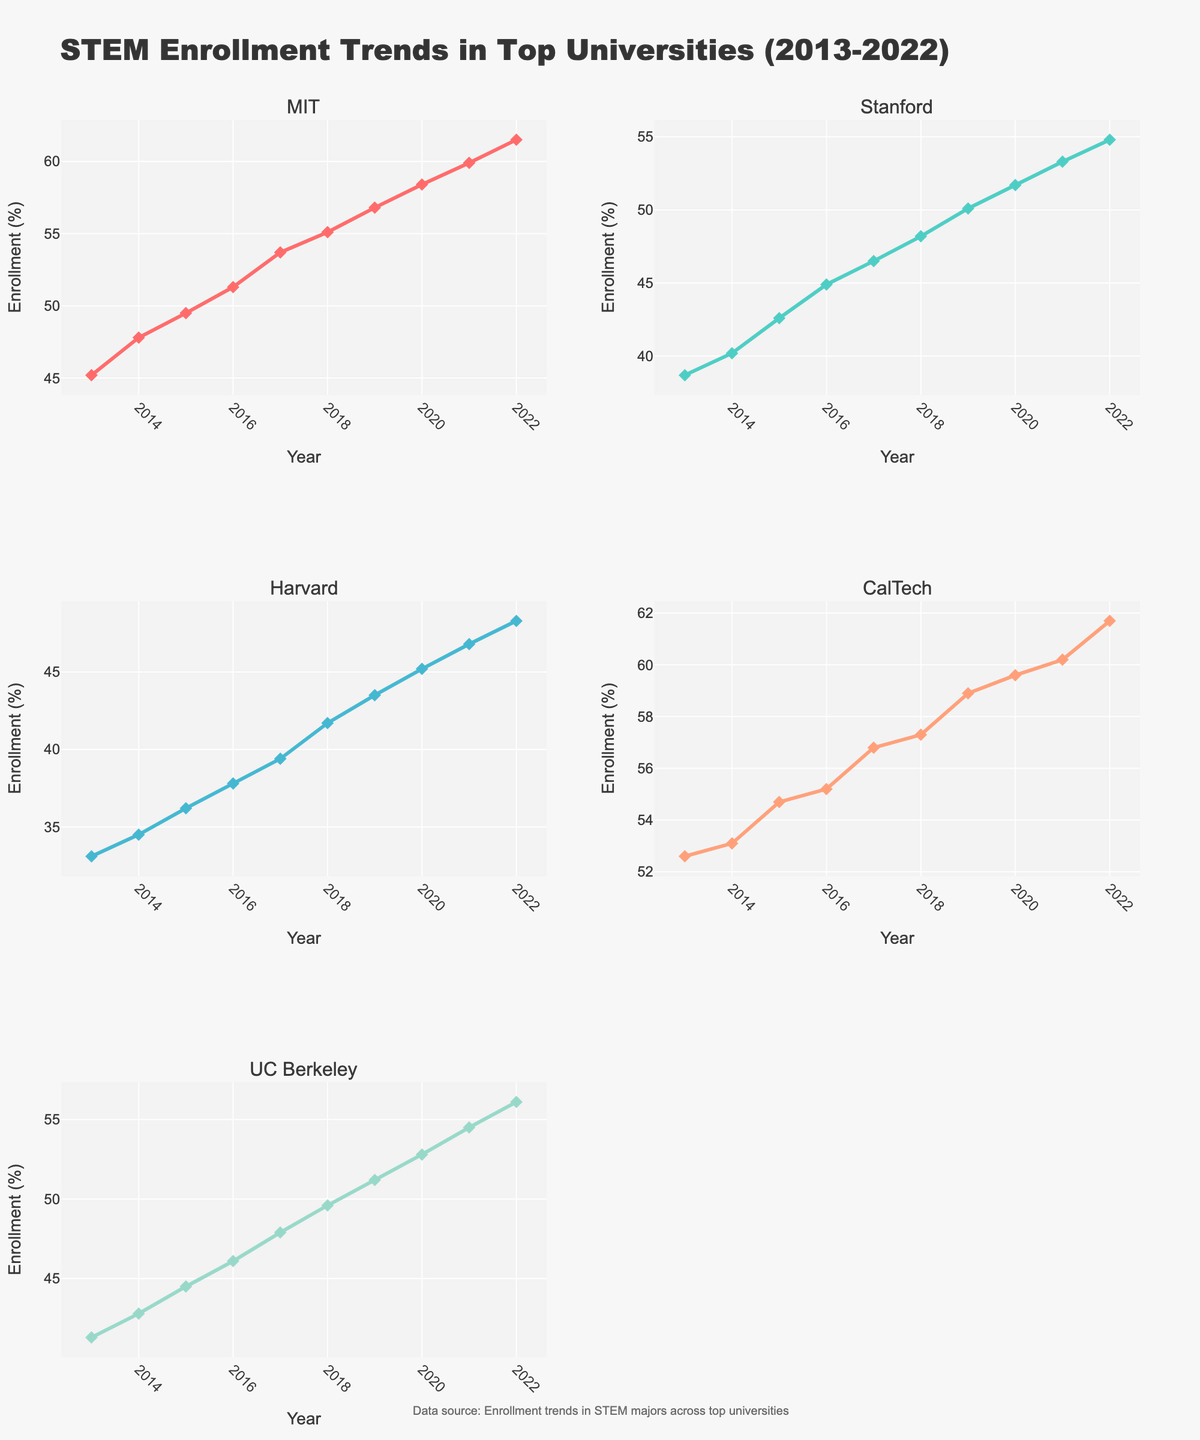What's the title of the figure? The title is usually placed at the top of a figure and it summarizes what the figure is about. Here, the title is "STEM Enrollment Trends in Top Universities (2013-2022)".
Answer: STEM Enrollment Trends in Top Universities (2013-2022) Which university had the highest STEM enrollment in 2022? To determine the university with the highest enrollment in 2022, observe the data points or lines corresponding to 2022 in each subplot. MIT's plot shows the highest value at approximately 61.5%.
Answer: MIT How did STEM enrollment at Harvard change from 2013 to 2022? Look at the subplot for Harvard. Observe the trendline from 2013 to 2022. Harvard's enrollment started around 33.1% in 2013 and increased to approximately 48.3% in 2022.
Answer: Increased Which university had the lowest increase in STEM enrollment over the decade? Calculate the increase for each university by subtracting the 2013 value from the 2022 value for each subplot. The smallest increment is seen for Harvard (48.3% - 33.1% = 15.2%).
Answer: Harvard What's the average STEM enrollment at UC Berkeley over the period shown? Sum the yearly percentages for UC Berkeley and divide by the number of years (10). (41.3 + 42.8 + 44.5 + 46.1 + 47.9 + 49.6 + 51.2 + 52.8 + 54.5 + 56.1) / 10 = 48.68%.
Answer: 48.68% Compare the trends of Stanford and CalTech from 2013 to 2022. Which university had a steeper increase? Observe the slopes of the trendlines in the subplots for Stanford and CalTech. Calculate the difference between 2022 and 2013 values for each. Stanford's increase: (54.8% - 38.7% = 16.1%), CalTech's increase: (61.7% - 52.6% = 9.1%). Therefore, Stanford had a steeper increase.
Answer: Stanford What is the difference in STEM enrollment between the highest and lowest enrollment universities in 2020? Identify the enrollment in 2020 for all universities from the subplots. Highest is MIT at 58.4%, lowest is Harvard at 45.2%. Difference is 58.4% - 45.2% = 13.2%.
Answer: 13.2% What's the median STEM enrollment percentage for all universities in 2015? Extract the 2015 values and sort them: [36.2 (Harvard), 42.6 (Stanford), 44.5 (UC Berkeley), 49.5 (MIT), 54.7 (CalTech)]. The median value is the middle one, which is 44.5%.
Answer: 44.5% In which year did MIT surpass 50% STEM enrollment? Check the subplot for MIT and observe the enrollment percentages year by year. MIT surpassed 50% in 2016.
Answer: 2016 